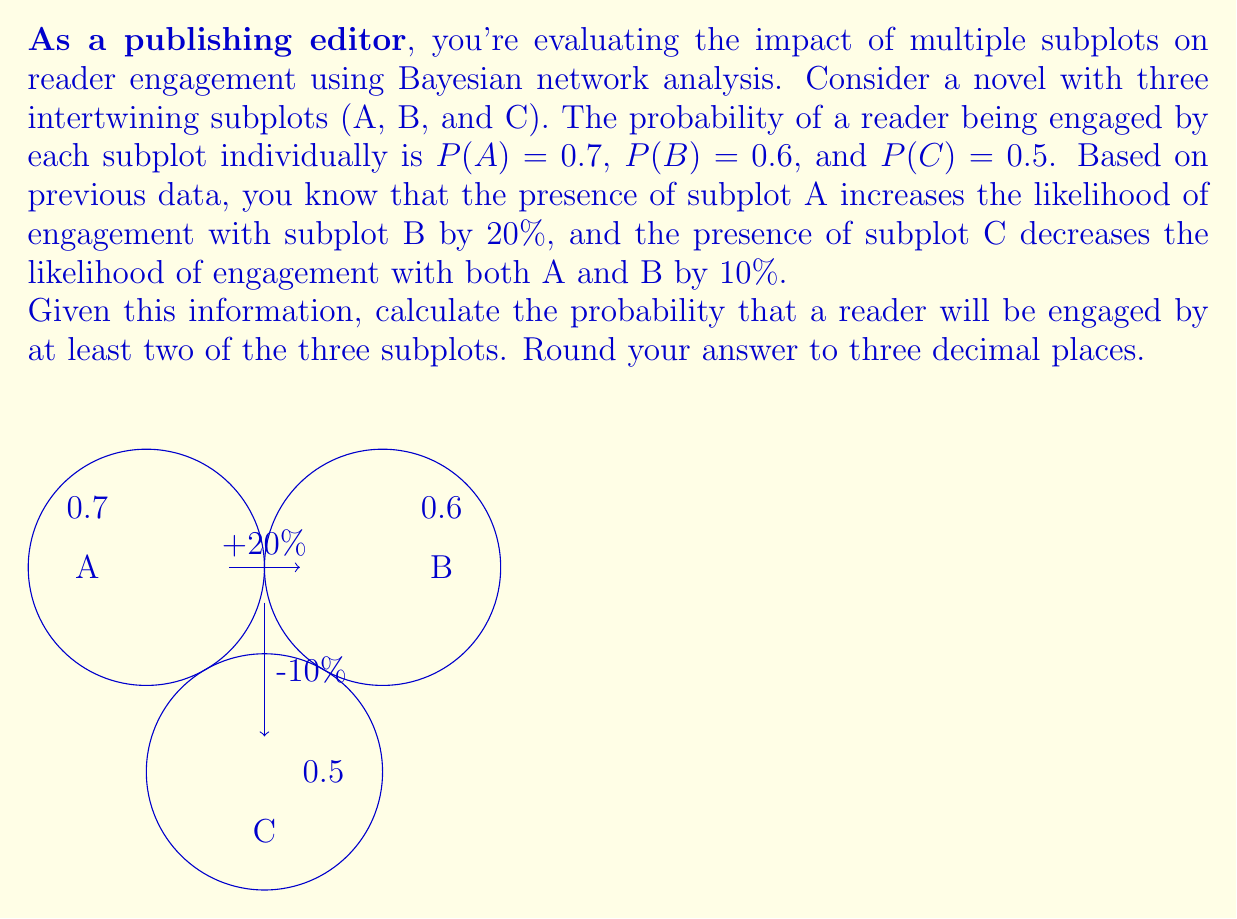Show me your answer to this math problem. To solve this problem, we'll use Bayesian network analysis and the inclusion-exclusion principle. Let's break it down step-by-step:

1) First, we need to calculate the adjusted probabilities for subplots B and C, given their interactions:

   P(B|A) = P(B) + 20% = 0.6 + 0.12 = 0.72
   P(A|C) = P(A) - 10% = 0.7 - 0.07 = 0.63
   P(B|C) = P(B) - 10% = 0.6 - 0.06 = 0.54

2) Now, we can calculate the probabilities of engagement for each combination:

   P(A ∩ B) = P(A) × P(B|A) = 0.7 × 0.72 = 0.504
   P(A ∩ C) = P(C) × P(A|C) = 0.5 × 0.63 = 0.315
   P(B ∩ C) = P(C) × P(B|C) = 0.5 × 0.54 = 0.27

3) To find the probability of at least two subplots engaging the reader, we'll use the inclusion-exclusion principle:

   P(at least two) = P(A ∩ B) + P(A ∩ C) + P(B ∩ C) - 2P(A ∩ B ∩ C)

4) We need to calculate P(A ∩ B ∩ C):

   P(A ∩ B ∩ C) = P(C) × P(A|C) × P(B|A,C)
                 = 0.5 × 0.63 × 0.72 = 0.2268

5) Now we can plug everything into our formula:

   P(at least two) = 0.504 + 0.315 + 0.27 - 2(0.2268)
                   = 1.089 - 0.4536
                   = 0.6354

6) Rounding to three decimal places:

   P(at least two) ≈ 0.635
Answer: 0.635 